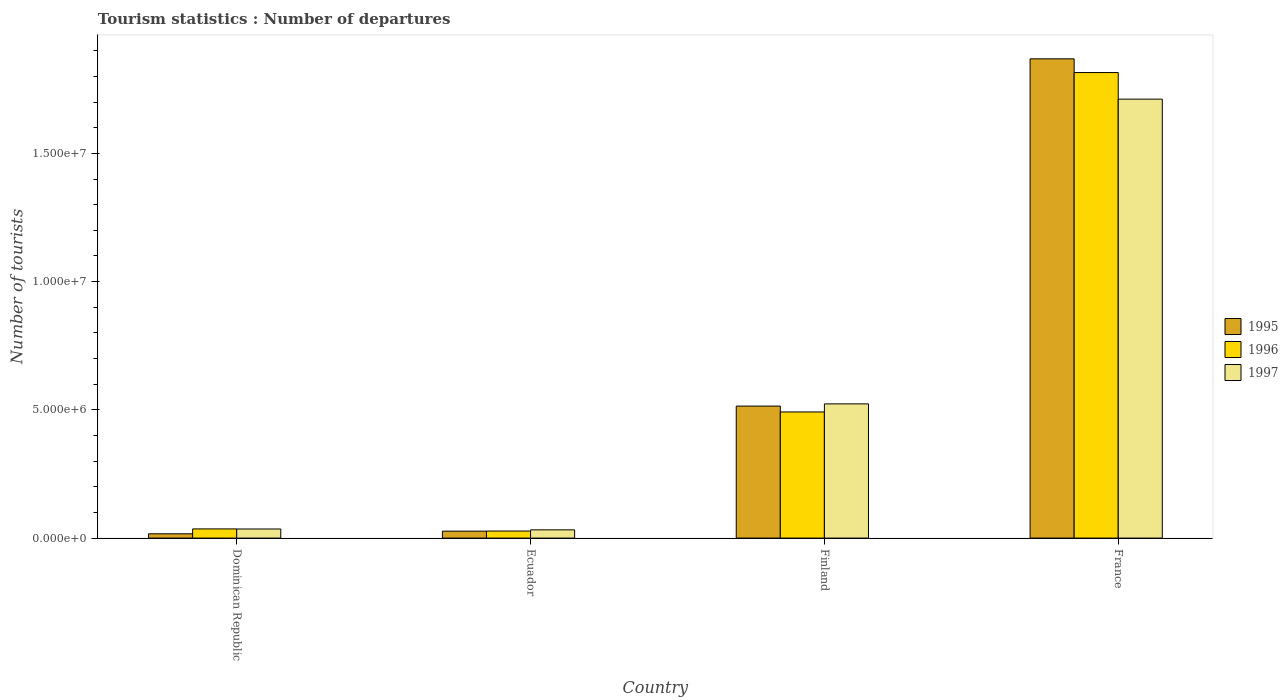Are the number of bars on each tick of the X-axis equal?
Provide a succinct answer. Yes. How many bars are there on the 3rd tick from the left?
Provide a short and direct response. 3. What is the label of the 2nd group of bars from the left?
Ensure brevity in your answer.  Ecuador. In how many cases, is the number of bars for a given country not equal to the number of legend labels?
Give a very brief answer. 0. What is the number of tourist departures in 1997 in Finland?
Provide a short and direct response. 5.23e+06. Across all countries, what is the maximum number of tourist departures in 1996?
Make the answer very short. 1.82e+07. Across all countries, what is the minimum number of tourist departures in 1997?
Provide a succinct answer. 3.21e+05. In which country was the number of tourist departures in 1995 maximum?
Your response must be concise. France. In which country was the number of tourist departures in 1997 minimum?
Make the answer very short. Ecuador. What is the total number of tourist departures in 1997 in the graph?
Your answer should be compact. 2.30e+07. What is the difference between the number of tourist departures in 1996 in Ecuador and that in Finland?
Provide a short and direct response. -4.64e+06. What is the difference between the number of tourist departures in 1997 in Finland and the number of tourist departures in 1995 in Dominican Republic?
Your answer should be compact. 5.06e+06. What is the average number of tourist departures in 1995 per country?
Your answer should be compact. 6.07e+06. What is the difference between the number of tourist departures of/in 1995 and number of tourist departures of/in 1997 in Finland?
Keep it short and to the point. -8.60e+04. In how many countries, is the number of tourist departures in 1995 greater than 7000000?
Offer a very short reply. 1. What is the ratio of the number of tourist departures in 1995 in Ecuador to that in Finland?
Your answer should be very brief. 0.05. What is the difference between the highest and the second highest number of tourist departures in 1997?
Keep it short and to the point. 1.19e+07. What is the difference between the highest and the lowest number of tourist departures in 1996?
Provide a succinct answer. 1.79e+07. Is the sum of the number of tourist departures in 1996 in Ecuador and Finland greater than the maximum number of tourist departures in 1997 across all countries?
Provide a succinct answer. No. Is it the case that in every country, the sum of the number of tourist departures in 1997 and number of tourist departures in 1995 is greater than the number of tourist departures in 1996?
Provide a succinct answer. Yes. How many bars are there?
Keep it short and to the point. 12. Are the values on the major ticks of Y-axis written in scientific E-notation?
Provide a short and direct response. Yes. Does the graph contain grids?
Make the answer very short. No. What is the title of the graph?
Ensure brevity in your answer.  Tourism statistics : Number of departures. What is the label or title of the X-axis?
Offer a terse response. Country. What is the label or title of the Y-axis?
Offer a very short reply. Number of tourists. What is the Number of tourists in 1995 in Dominican Republic?
Offer a very short reply. 1.68e+05. What is the Number of tourists of 1996 in Dominican Republic?
Provide a short and direct response. 3.58e+05. What is the Number of tourists in 1997 in Dominican Republic?
Your answer should be compact. 3.55e+05. What is the Number of tourists of 1995 in Ecuador?
Give a very brief answer. 2.71e+05. What is the Number of tourists in 1996 in Ecuador?
Provide a succinct answer. 2.75e+05. What is the Number of tourists of 1997 in Ecuador?
Ensure brevity in your answer.  3.21e+05. What is the Number of tourists in 1995 in Finland?
Your answer should be compact. 5.15e+06. What is the Number of tourists in 1996 in Finland?
Provide a succinct answer. 4.92e+06. What is the Number of tourists of 1997 in Finland?
Provide a succinct answer. 5.23e+06. What is the Number of tourists of 1995 in France?
Offer a terse response. 1.87e+07. What is the Number of tourists of 1996 in France?
Provide a short and direct response. 1.82e+07. What is the Number of tourists in 1997 in France?
Your response must be concise. 1.71e+07. Across all countries, what is the maximum Number of tourists of 1995?
Make the answer very short. 1.87e+07. Across all countries, what is the maximum Number of tourists of 1996?
Provide a succinct answer. 1.82e+07. Across all countries, what is the maximum Number of tourists in 1997?
Offer a very short reply. 1.71e+07. Across all countries, what is the minimum Number of tourists in 1995?
Provide a succinct answer. 1.68e+05. Across all countries, what is the minimum Number of tourists in 1996?
Offer a terse response. 2.75e+05. Across all countries, what is the minimum Number of tourists of 1997?
Give a very brief answer. 3.21e+05. What is the total Number of tourists in 1995 in the graph?
Offer a very short reply. 2.43e+07. What is the total Number of tourists of 1996 in the graph?
Offer a very short reply. 2.37e+07. What is the total Number of tourists in 1997 in the graph?
Your answer should be very brief. 2.30e+07. What is the difference between the Number of tourists in 1995 in Dominican Republic and that in Ecuador?
Your response must be concise. -1.03e+05. What is the difference between the Number of tourists in 1996 in Dominican Republic and that in Ecuador?
Your response must be concise. 8.30e+04. What is the difference between the Number of tourists in 1997 in Dominican Republic and that in Ecuador?
Your response must be concise. 3.40e+04. What is the difference between the Number of tourists in 1995 in Dominican Republic and that in Finland?
Provide a short and direct response. -4.98e+06. What is the difference between the Number of tourists in 1996 in Dominican Republic and that in Finland?
Offer a terse response. -4.56e+06. What is the difference between the Number of tourists in 1997 in Dominican Republic and that in Finland?
Offer a very short reply. -4.88e+06. What is the difference between the Number of tourists of 1995 in Dominican Republic and that in France?
Your answer should be very brief. -1.85e+07. What is the difference between the Number of tourists in 1996 in Dominican Republic and that in France?
Keep it short and to the point. -1.78e+07. What is the difference between the Number of tourists of 1997 in Dominican Republic and that in France?
Make the answer very short. -1.68e+07. What is the difference between the Number of tourists in 1995 in Ecuador and that in Finland?
Your answer should be very brief. -4.88e+06. What is the difference between the Number of tourists in 1996 in Ecuador and that in Finland?
Your answer should be very brief. -4.64e+06. What is the difference between the Number of tourists in 1997 in Ecuador and that in Finland?
Give a very brief answer. -4.91e+06. What is the difference between the Number of tourists in 1995 in Ecuador and that in France?
Ensure brevity in your answer.  -1.84e+07. What is the difference between the Number of tourists in 1996 in Ecuador and that in France?
Provide a succinct answer. -1.79e+07. What is the difference between the Number of tourists in 1997 in Ecuador and that in France?
Your answer should be very brief. -1.68e+07. What is the difference between the Number of tourists in 1995 in Finland and that in France?
Ensure brevity in your answer.  -1.35e+07. What is the difference between the Number of tourists in 1996 in Finland and that in France?
Ensure brevity in your answer.  -1.32e+07. What is the difference between the Number of tourists in 1997 in Finland and that in France?
Keep it short and to the point. -1.19e+07. What is the difference between the Number of tourists in 1995 in Dominican Republic and the Number of tourists in 1996 in Ecuador?
Provide a succinct answer. -1.07e+05. What is the difference between the Number of tourists in 1995 in Dominican Republic and the Number of tourists in 1997 in Ecuador?
Your response must be concise. -1.53e+05. What is the difference between the Number of tourists of 1996 in Dominican Republic and the Number of tourists of 1997 in Ecuador?
Make the answer very short. 3.70e+04. What is the difference between the Number of tourists of 1995 in Dominican Republic and the Number of tourists of 1996 in Finland?
Ensure brevity in your answer.  -4.75e+06. What is the difference between the Number of tourists of 1995 in Dominican Republic and the Number of tourists of 1997 in Finland?
Offer a very short reply. -5.06e+06. What is the difference between the Number of tourists of 1996 in Dominican Republic and the Number of tourists of 1997 in Finland?
Offer a terse response. -4.88e+06. What is the difference between the Number of tourists in 1995 in Dominican Republic and the Number of tourists in 1996 in France?
Your response must be concise. -1.80e+07. What is the difference between the Number of tourists of 1995 in Dominican Republic and the Number of tourists of 1997 in France?
Give a very brief answer. -1.69e+07. What is the difference between the Number of tourists of 1996 in Dominican Republic and the Number of tourists of 1997 in France?
Give a very brief answer. -1.68e+07. What is the difference between the Number of tourists of 1995 in Ecuador and the Number of tourists of 1996 in Finland?
Your answer should be compact. -4.65e+06. What is the difference between the Number of tourists in 1995 in Ecuador and the Number of tourists in 1997 in Finland?
Your answer should be compact. -4.96e+06. What is the difference between the Number of tourists in 1996 in Ecuador and the Number of tourists in 1997 in Finland?
Your response must be concise. -4.96e+06. What is the difference between the Number of tourists of 1995 in Ecuador and the Number of tourists of 1996 in France?
Your answer should be very brief. -1.79e+07. What is the difference between the Number of tourists in 1995 in Ecuador and the Number of tourists in 1997 in France?
Make the answer very short. -1.68e+07. What is the difference between the Number of tourists in 1996 in Ecuador and the Number of tourists in 1997 in France?
Make the answer very short. -1.68e+07. What is the difference between the Number of tourists of 1995 in Finland and the Number of tourists of 1996 in France?
Your response must be concise. -1.30e+07. What is the difference between the Number of tourists of 1995 in Finland and the Number of tourists of 1997 in France?
Offer a very short reply. -1.20e+07. What is the difference between the Number of tourists of 1996 in Finland and the Number of tourists of 1997 in France?
Keep it short and to the point. -1.22e+07. What is the average Number of tourists of 1995 per country?
Keep it short and to the point. 6.07e+06. What is the average Number of tourists in 1996 per country?
Keep it short and to the point. 5.93e+06. What is the average Number of tourists of 1997 per country?
Give a very brief answer. 5.76e+06. What is the difference between the Number of tourists in 1995 and Number of tourists in 1996 in Dominican Republic?
Your answer should be very brief. -1.90e+05. What is the difference between the Number of tourists in 1995 and Number of tourists in 1997 in Dominican Republic?
Offer a terse response. -1.87e+05. What is the difference between the Number of tourists of 1996 and Number of tourists of 1997 in Dominican Republic?
Offer a very short reply. 3000. What is the difference between the Number of tourists of 1995 and Number of tourists of 1996 in Ecuador?
Your answer should be very brief. -4000. What is the difference between the Number of tourists in 1995 and Number of tourists in 1997 in Ecuador?
Make the answer very short. -5.00e+04. What is the difference between the Number of tourists in 1996 and Number of tourists in 1997 in Ecuador?
Give a very brief answer. -4.60e+04. What is the difference between the Number of tourists of 1995 and Number of tourists of 1996 in Finland?
Make the answer very short. 2.29e+05. What is the difference between the Number of tourists of 1995 and Number of tourists of 1997 in Finland?
Offer a very short reply. -8.60e+04. What is the difference between the Number of tourists of 1996 and Number of tourists of 1997 in Finland?
Your response must be concise. -3.15e+05. What is the difference between the Number of tourists in 1995 and Number of tourists in 1996 in France?
Offer a terse response. 5.35e+05. What is the difference between the Number of tourists in 1995 and Number of tourists in 1997 in France?
Your answer should be compact. 1.57e+06. What is the difference between the Number of tourists in 1996 and Number of tourists in 1997 in France?
Make the answer very short. 1.04e+06. What is the ratio of the Number of tourists in 1995 in Dominican Republic to that in Ecuador?
Provide a succinct answer. 0.62. What is the ratio of the Number of tourists of 1996 in Dominican Republic to that in Ecuador?
Your answer should be very brief. 1.3. What is the ratio of the Number of tourists in 1997 in Dominican Republic to that in Ecuador?
Ensure brevity in your answer.  1.11. What is the ratio of the Number of tourists in 1995 in Dominican Republic to that in Finland?
Provide a short and direct response. 0.03. What is the ratio of the Number of tourists of 1996 in Dominican Republic to that in Finland?
Provide a succinct answer. 0.07. What is the ratio of the Number of tourists in 1997 in Dominican Republic to that in Finland?
Your answer should be very brief. 0.07. What is the ratio of the Number of tourists of 1995 in Dominican Republic to that in France?
Make the answer very short. 0.01. What is the ratio of the Number of tourists in 1996 in Dominican Republic to that in France?
Keep it short and to the point. 0.02. What is the ratio of the Number of tourists of 1997 in Dominican Republic to that in France?
Ensure brevity in your answer.  0.02. What is the ratio of the Number of tourists of 1995 in Ecuador to that in Finland?
Ensure brevity in your answer.  0.05. What is the ratio of the Number of tourists of 1996 in Ecuador to that in Finland?
Offer a terse response. 0.06. What is the ratio of the Number of tourists in 1997 in Ecuador to that in Finland?
Keep it short and to the point. 0.06. What is the ratio of the Number of tourists of 1995 in Ecuador to that in France?
Offer a terse response. 0.01. What is the ratio of the Number of tourists in 1996 in Ecuador to that in France?
Ensure brevity in your answer.  0.02. What is the ratio of the Number of tourists of 1997 in Ecuador to that in France?
Provide a short and direct response. 0.02. What is the ratio of the Number of tourists in 1995 in Finland to that in France?
Your answer should be compact. 0.28. What is the ratio of the Number of tourists of 1996 in Finland to that in France?
Offer a very short reply. 0.27. What is the ratio of the Number of tourists in 1997 in Finland to that in France?
Provide a short and direct response. 0.31. What is the difference between the highest and the second highest Number of tourists of 1995?
Offer a terse response. 1.35e+07. What is the difference between the highest and the second highest Number of tourists of 1996?
Give a very brief answer. 1.32e+07. What is the difference between the highest and the second highest Number of tourists of 1997?
Give a very brief answer. 1.19e+07. What is the difference between the highest and the lowest Number of tourists in 1995?
Make the answer very short. 1.85e+07. What is the difference between the highest and the lowest Number of tourists in 1996?
Your response must be concise. 1.79e+07. What is the difference between the highest and the lowest Number of tourists of 1997?
Ensure brevity in your answer.  1.68e+07. 